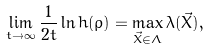<formula> <loc_0><loc_0><loc_500><loc_500>\lim _ { t \rightarrow { \infty } } { \frac { 1 } { 2 t } \ln { h ( \varrho ) } } = \max _ { \vec { X } \in \Lambda } { \lambda ( \vec { X } ) } ,</formula> 